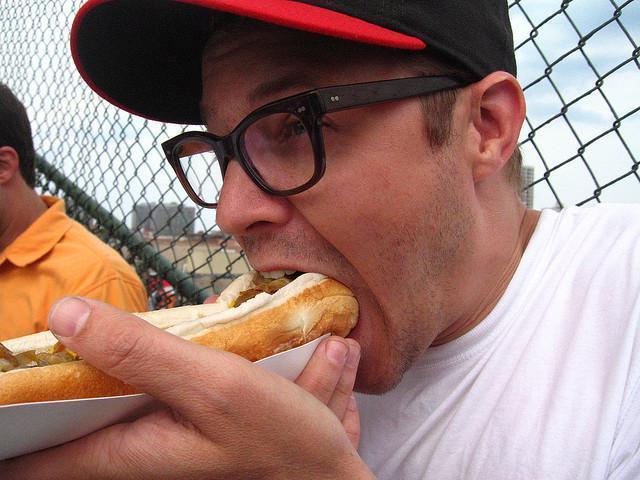How many people are there?
Give a very brief answer. 2. 